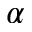<formula> <loc_0><loc_0><loc_500><loc_500>\alpha</formula> 